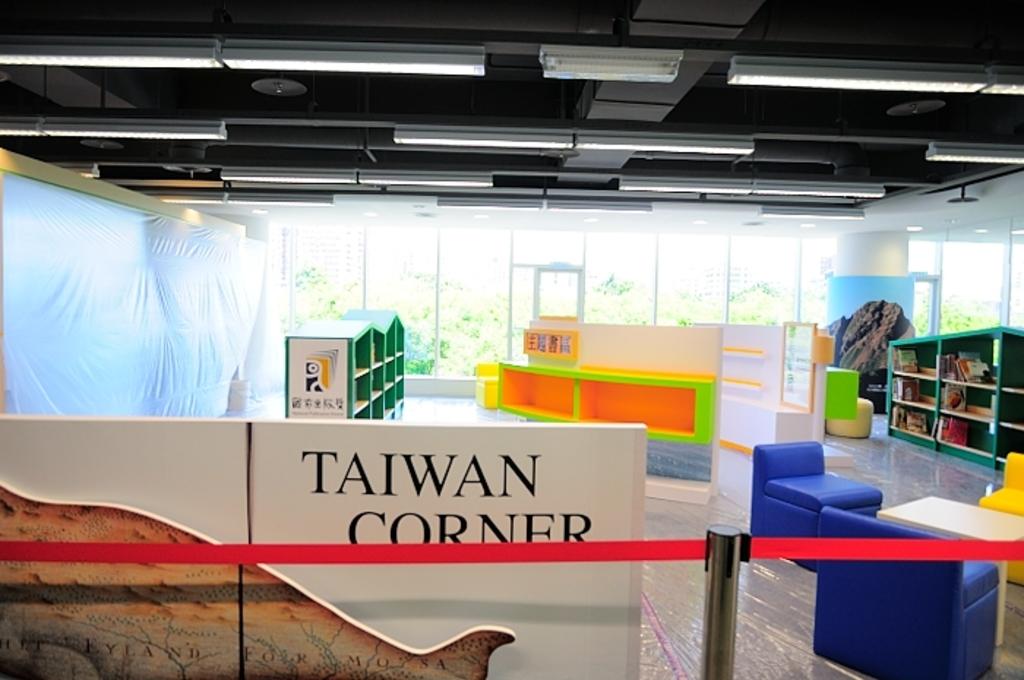What corner is it?
Your answer should be very brief. Taiwan corner. 